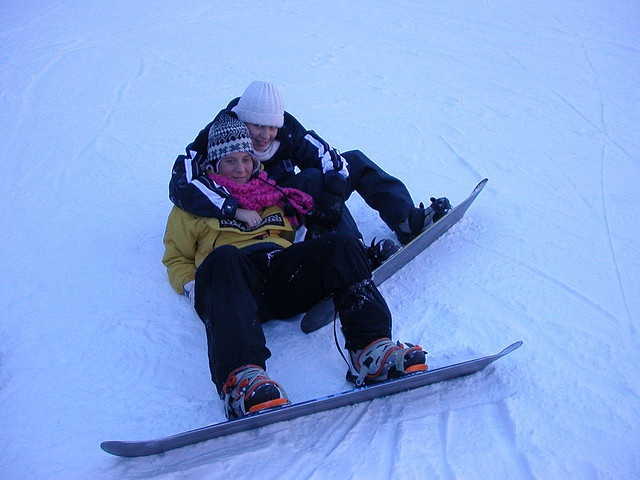Describe the objects in this image and their specific colors. I can see people in lightblue, black, navy, gray, and blue tones, people in lightblue, black, navy, and blue tones, snowboard in lightblue, navy, blue, and darkblue tones, and snowboard in lightblue, blue, navy, and black tones in this image. 